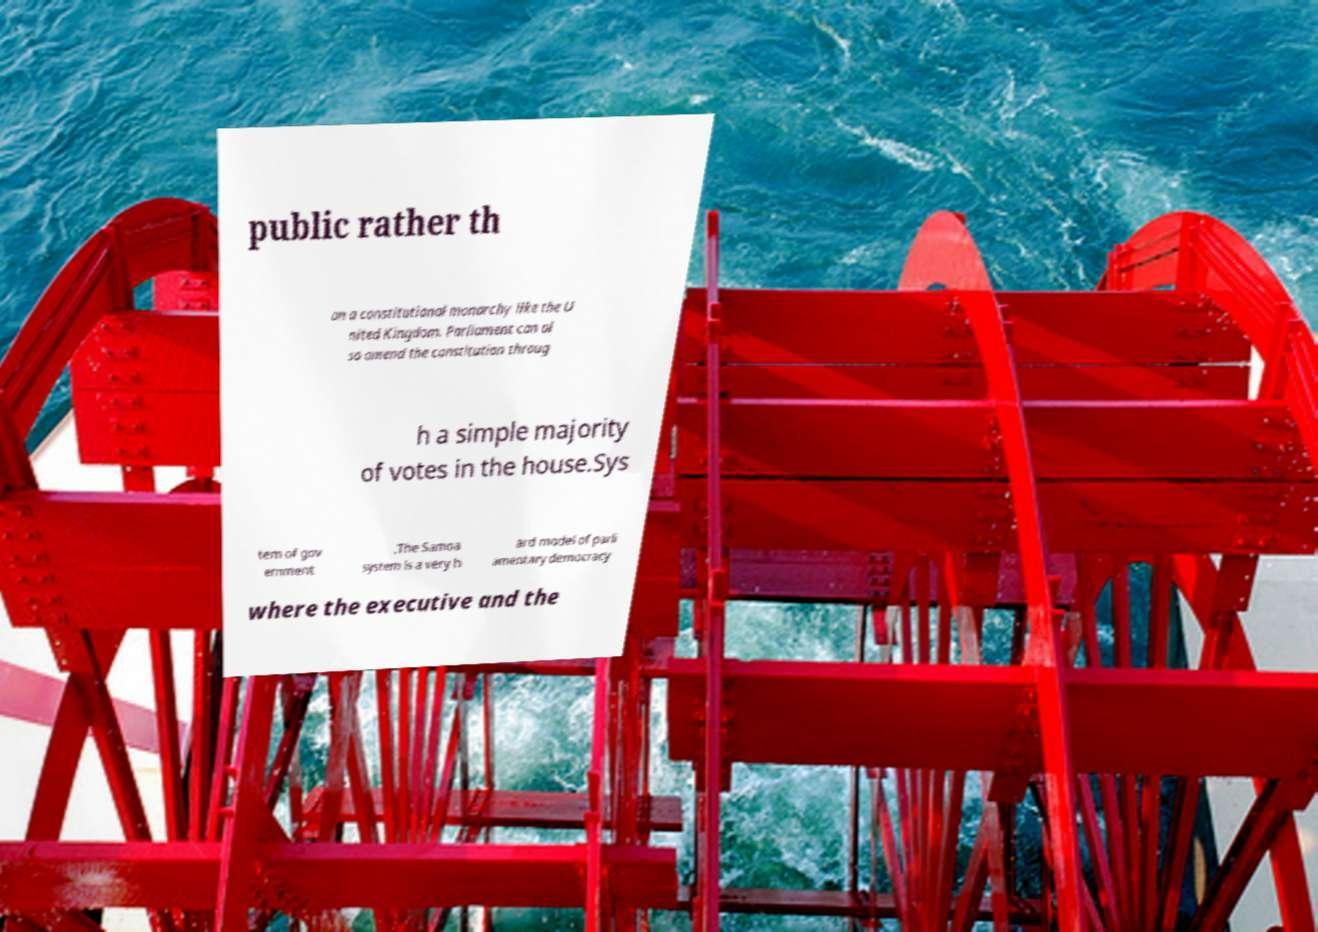There's text embedded in this image that I need extracted. Can you transcribe it verbatim? public rather th an a constitutional monarchy like the U nited Kingdom. Parliament can al so amend the constitution throug h a simple majority of votes in the house.Sys tem of gov ernment .The Samoa system is a very h ard model of parli amentary democracy where the executive and the 